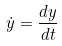Convert formula to latex. <formula><loc_0><loc_0><loc_500><loc_500>\dot { y } = \frac { d y } { d t }</formula> 